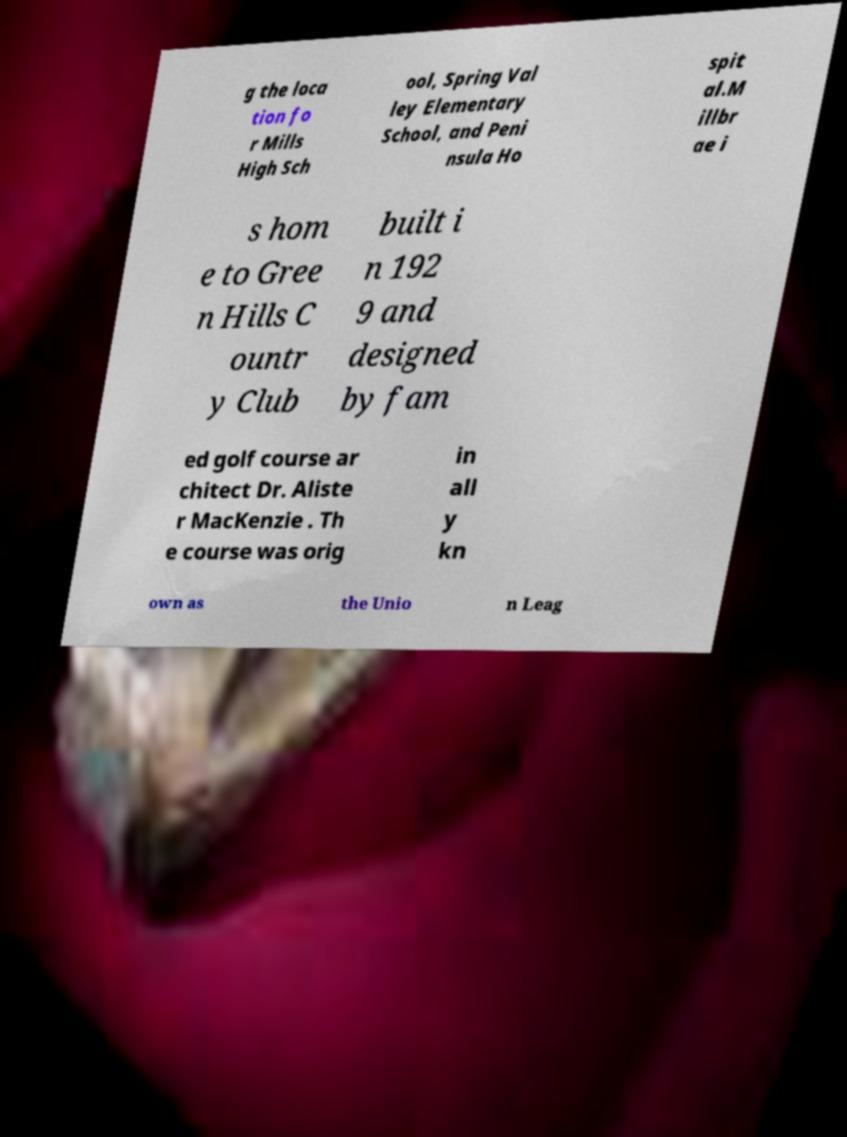Please read and relay the text visible in this image. What does it say? g the loca tion fo r Mills High Sch ool, Spring Val ley Elementary School, and Peni nsula Ho spit al.M illbr ae i s hom e to Gree n Hills C ountr y Club built i n 192 9 and designed by fam ed golf course ar chitect Dr. Aliste r MacKenzie . Th e course was orig in all y kn own as the Unio n Leag 